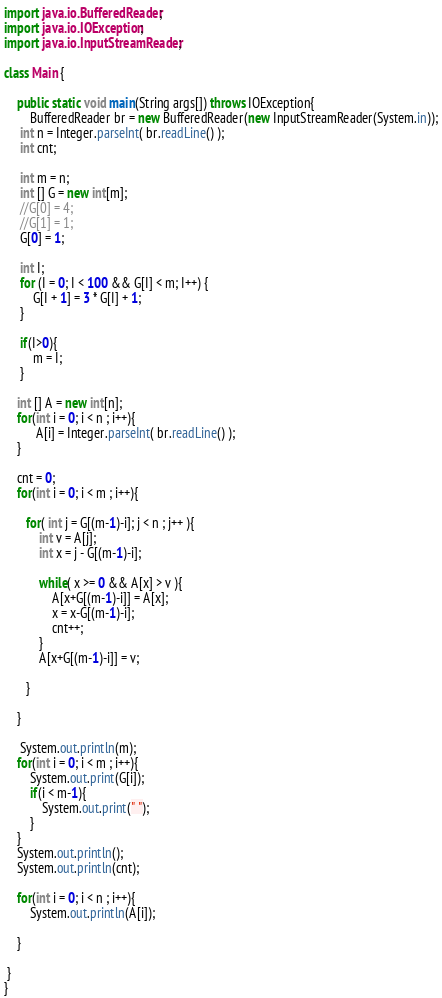Convert code to text. <code><loc_0><loc_0><loc_500><loc_500><_Java_>

import java.io.BufferedReader;
import java.io.IOException;
import java.io.InputStreamReader;

class Main {

	public static void main(String args[]) throws IOException{
		BufferedReader br = new BufferedReader(new InputStreamReader(System.in));
	 int n = Integer.parseInt( br.readLine() );
	 int cnt;

	 int m = n;
	 int [] G = new int[m];
	 //G[0] = 4;
     //G[1] = 1;
	 G[0] = 1;

	 int I;
	 for (I = 0; I < 100 && G[I] < m; I++) {
         G[I + 1] = 3 * G[I] + 1;
     }

     if(I>0){
    	 m = I;
     }

    int [] A = new int[n];
    for(int i = 0; i < n ; i++){
          A[i] = Integer.parseInt( br.readLine() );
    }

    cnt = 0;
    for(int i = 0; i < m ; i++){

       for( int j = G[(m-1)-i]; j < n ; j++ ){
    	   int v = A[j];
    	   int x = j - G[(m-1)-i];

    	   while( x >= 0 && A[x] > v ){
    		   A[x+G[(m-1)-i]] = A[x];
               x = x-G[(m-1)-i];
               cnt++;
    	   }
    	   A[x+G[(m-1)-i]] = v;

       }

    }

     System.out.println(m);
    for(int i = 0; i < m ; i++){
    	System.out.print(G[i]);
        if(i < m-1){
            System.out.print(" ");
        }
    }
    System.out.println();
    System.out.println(cnt);

    for(int i = 0; i < n ; i++){
    	System.out.println(A[i]);

    }

 }
}</code> 